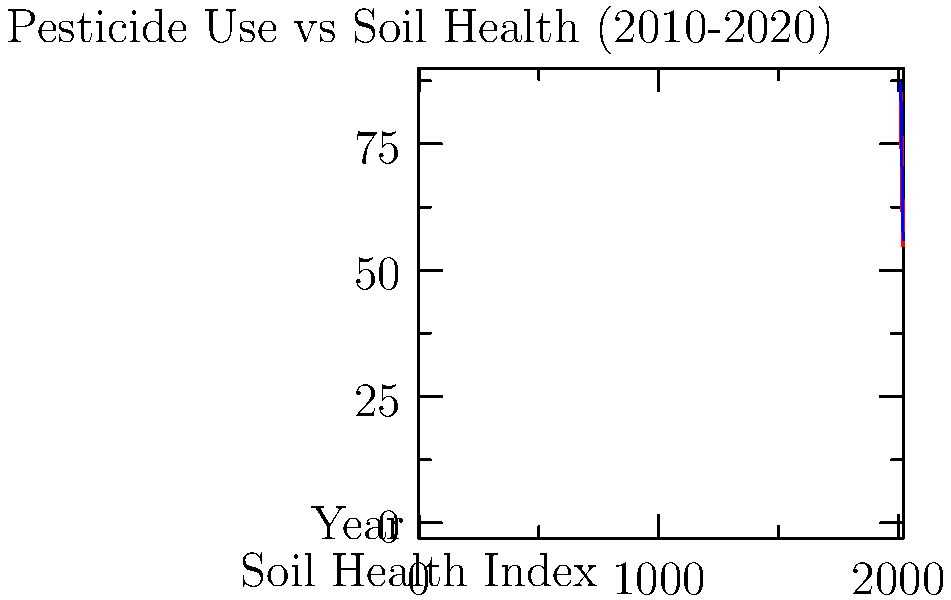Based on the scatter plot showing the relationship between pesticide use and soil health from 2010 to 2020, what can be concluded about the impact of pesticide use on soil health over time? How might this trend affect sustainable agriculture practices? To answer this question, let's analyze the scatter plot step-by-step:

1. Observe the overall trend: The red dots represent data points for soil health over the years. We can see a clear downward trend from 2010 to 2020.

2. Interpret the y-axis: The y-axis represents the Soil Health Index, with higher values indicating better soil health.

3. Analyze the change: In 2010, the Soil Health Index was around 85. By 2020, it had decreased to approximately 55. This represents a significant decline in soil health over the decade.

4. Consider the relationship: Although pesticide use is not directly shown, the question implies that the decline in soil health is related to pesticide use. This suggests an inverse relationship between pesticide use and soil health.

5. Evaluate the impact on sustainable agriculture:
   a) Declining soil health can lead to reduced crop yields and quality.
   b) Poor soil health may require more inputs (fertilizers, water) to maintain productivity.
   c) This trend is contrary to sustainable agriculture practices, which aim to maintain or improve soil health over time.

6. Consider potential solutions:
   a) Reducing pesticide use or adopting integrated pest management strategies.
   b) Implementing crop rotation and cover cropping to improve soil health.
   c) Using organic farming methods to minimize chemical inputs.

The data clearly shows that current agricultural practices, likely including heavy pesticide use, are detrimental to long-term soil health and sustainability.
Answer: Pesticide use is negatively correlated with soil health, indicating unsustainable agricultural practices that require immediate attention and change to preserve long-term soil productivity. 